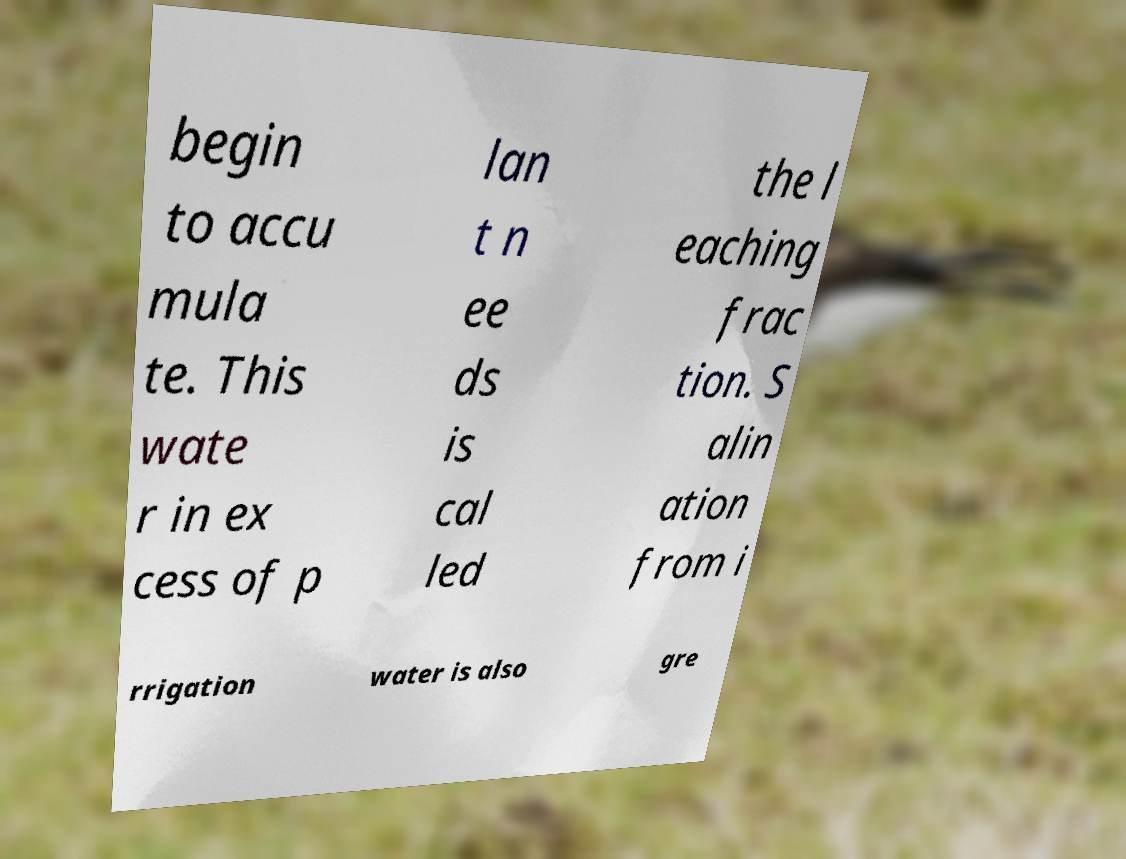Please identify and transcribe the text found in this image. begin to accu mula te. This wate r in ex cess of p lan t n ee ds is cal led the l eaching frac tion. S alin ation from i rrigation water is also gre 